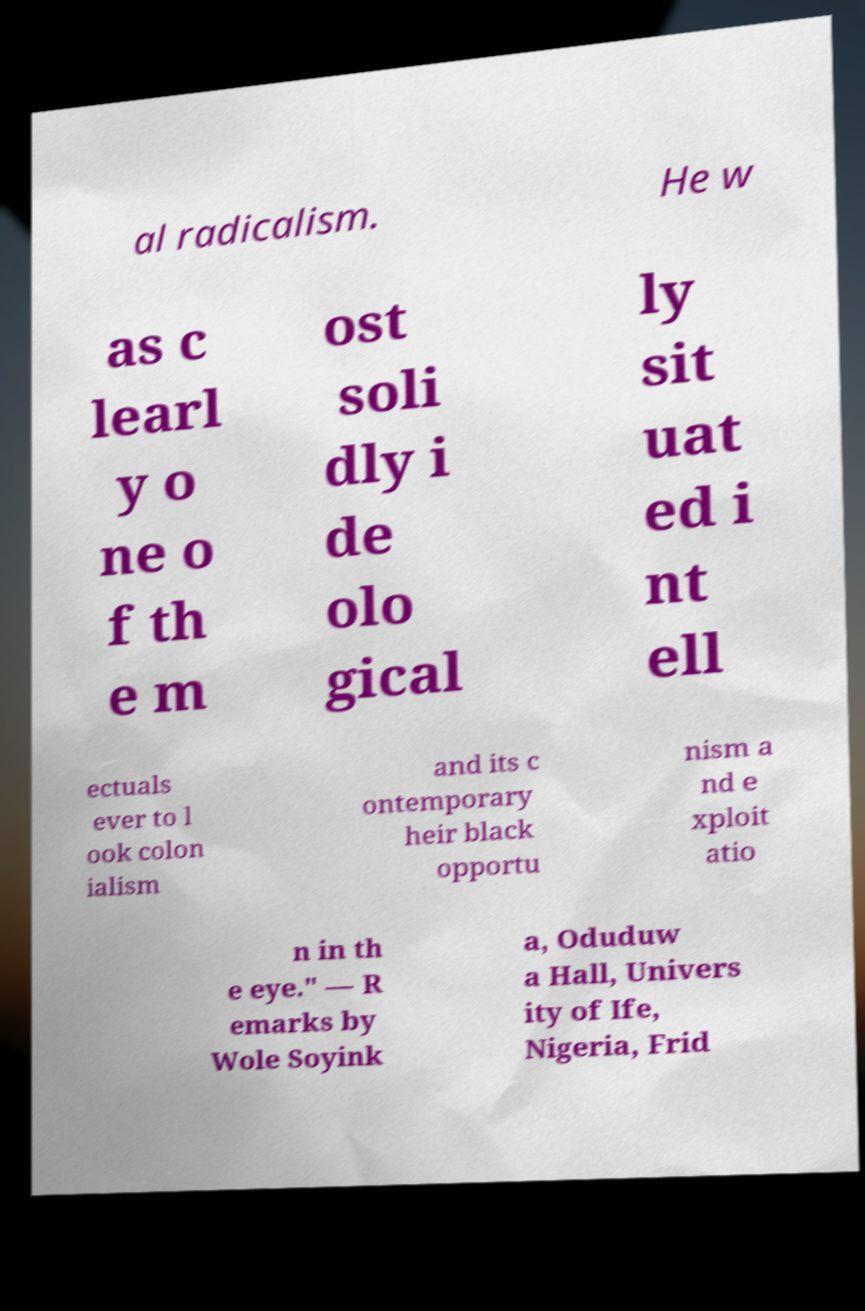For documentation purposes, I need the text within this image transcribed. Could you provide that? al radicalism. He w as c learl y o ne o f th e m ost soli dly i de olo gical ly sit uat ed i nt ell ectuals ever to l ook colon ialism and its c ontemporary heir black opportu nism a nd e xploit atio n in th e eye." — R emarks by Wole Soyink a, Oduduw a Hall, Univers ity of Ife, Nigeria, Frid 